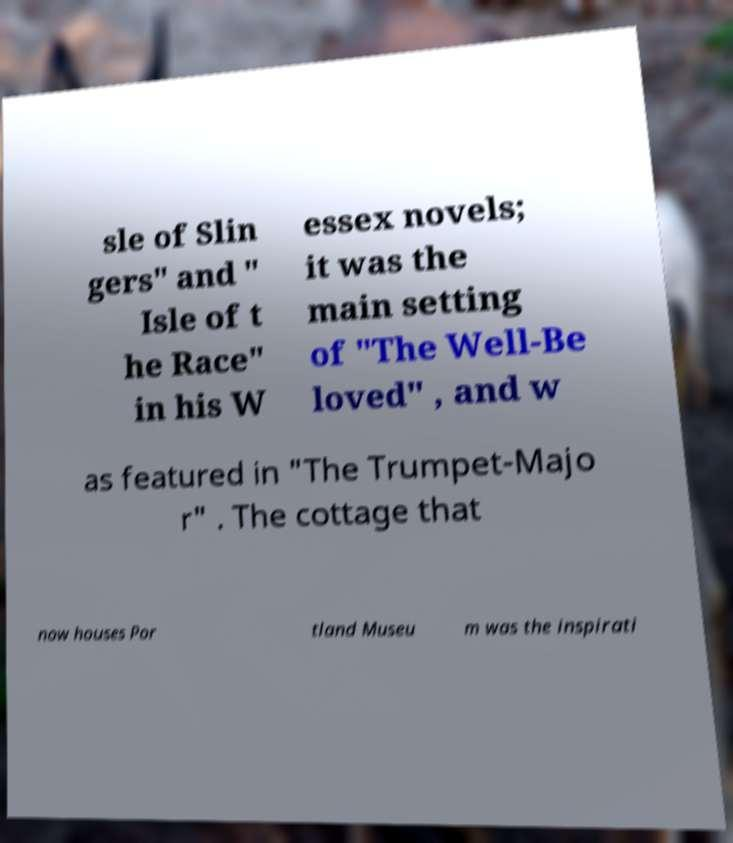Please read and relay the text visible in this image. What does it say? sle of Slin gers" and " Isle of t he Race" in his W essex novels; it was the main setting of "The Well-Be loved" , and w as featured in "The Trumpet-Majo r" . The cottage that now houses Por tland Museu m was the inspirati 